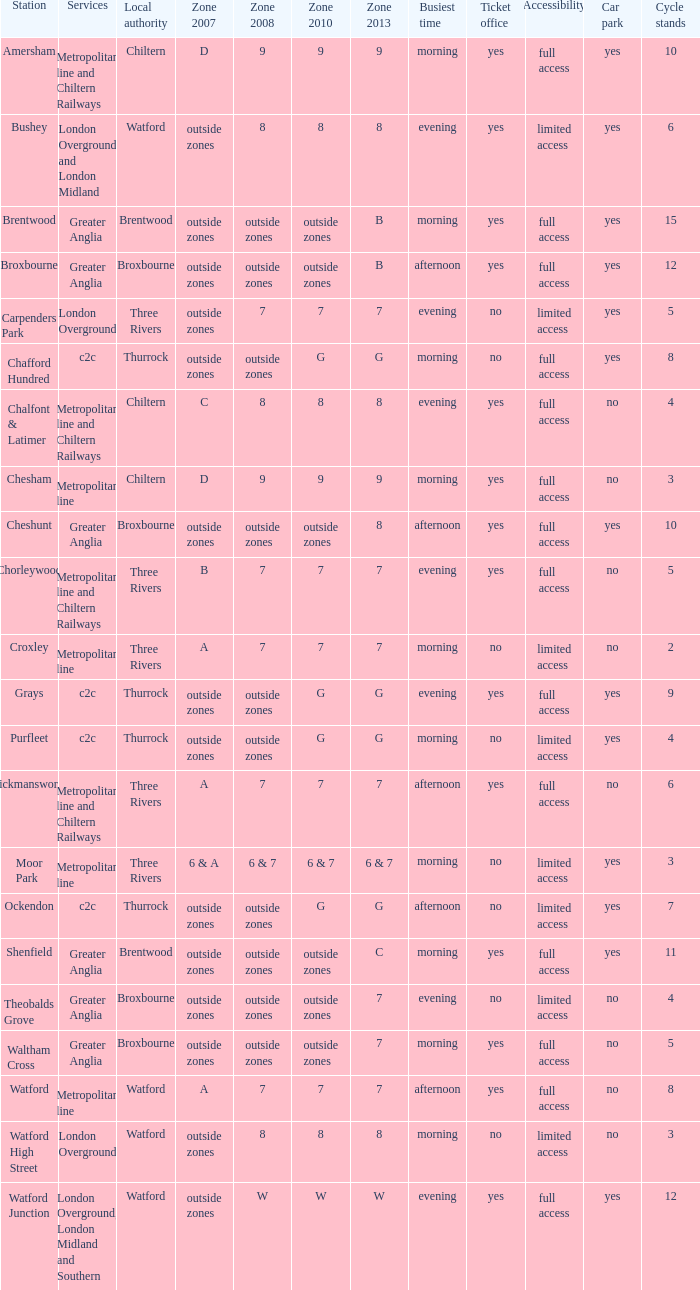Which Local authority has a Zone 2007 of outside zones, and a Zone 2008 of outside zones, and a Zone 2010 of outside zones, and a Station of waltham cross? Broxbourne. 